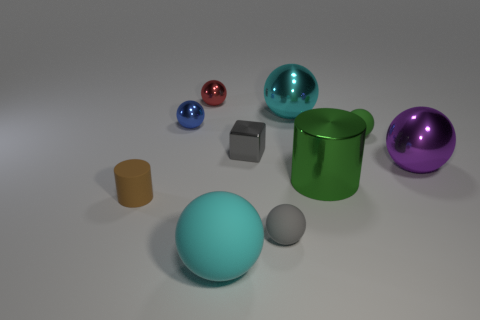What's the relation between the colorful objects in terms of positioning? The arrangement of the colorful objects appears quite deliberate, creating a visual balance. The green metallic cylinder on the right is parallel to the red and blue metallic spheres, while the purple shiny sphere occupies the center. The spheres are placed in a triangular formation with the purple sphere as the focal point, while the red and blue are symmetrically aligned on either side. 